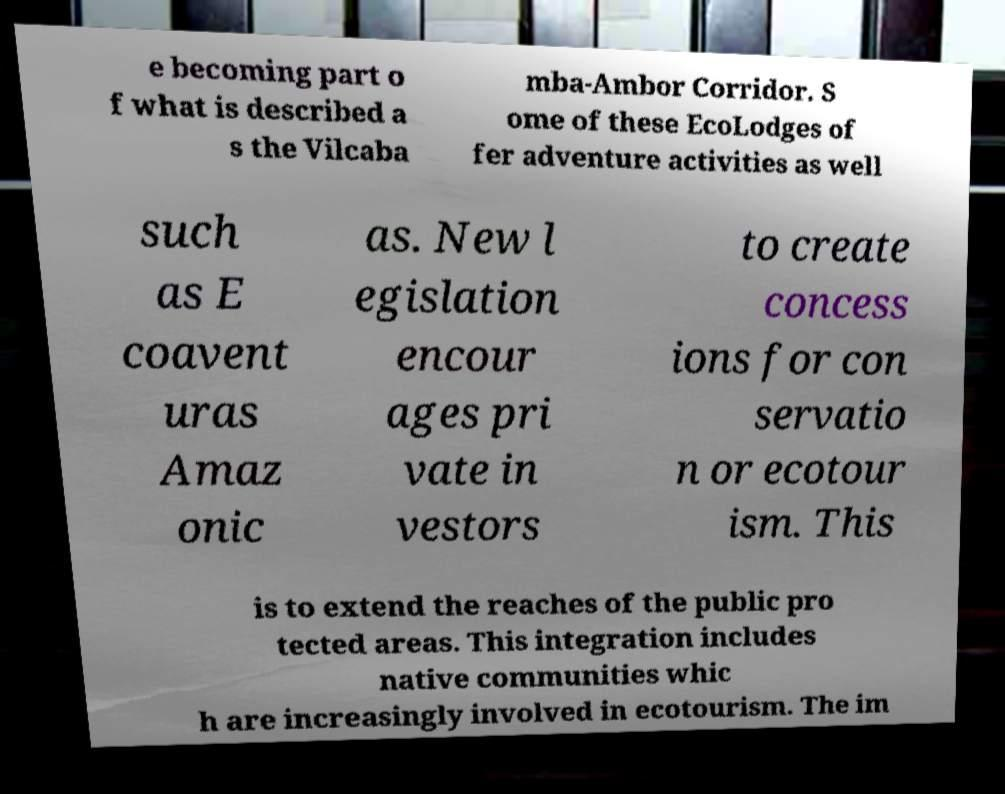Could you extract and type out the text from this image? e becoming part o f what is described a s the Vilcaba mba-Ambor Corridor. S ome of these EcoLodges of fer adventure activities as well such as E coavent uras Amaz onic as. New l egislation encour ages pri vate in vestors to create concess ions for con servatio n or ecotour ism. This is to extend the reaches of the public pro tected areas. This integration includes native communities whic h are increasingly involved in ecotourism. The im 